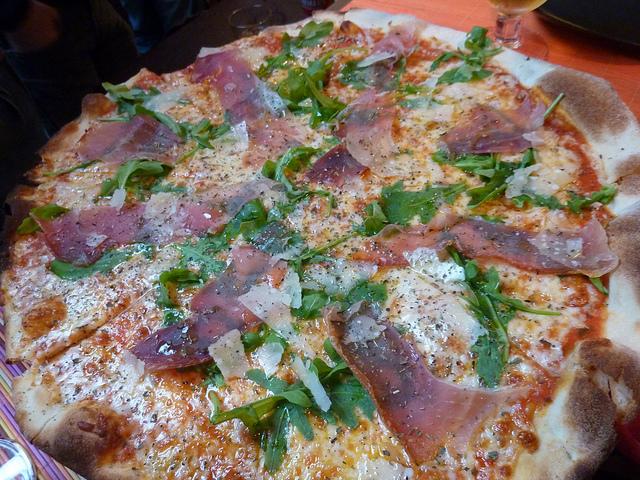What besides cheese is the pizza topped with?
Answer briefly. Ham. Is it a baked pizza?
Short answer required. Yes. What pizza type is this?
Write a very short answer. Salami. What is the white stuff?
Give a very brief answer. Cheese. What are the green objects?
Short answer required. Parsley. Are there mushrooms on the pizza?
Give a very brief answer. No. What color is the vegetable topping?
Keep it brief. Green. Would this taste sweet?
Write a very short answer. No. Is there fruit on this pizza?
Write a very short answer. No. Does this dish contain potatoes?
Short answer required. No. Is this food healthy?
Quick response, please. No. Has someone eaten the pizza?
Be succinct. No. 